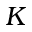Convert formula to latex. <formula><loc_0><loc_0><loc_500><loc_500>K</formula> 